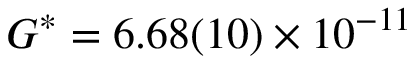<formula> <loc_0><loc_0><loc_500><loc_500>G ^ { * } = 6 . 6 8 ( 1 0 ) \times 1 0 ^ { - 1 1 }</formula> 